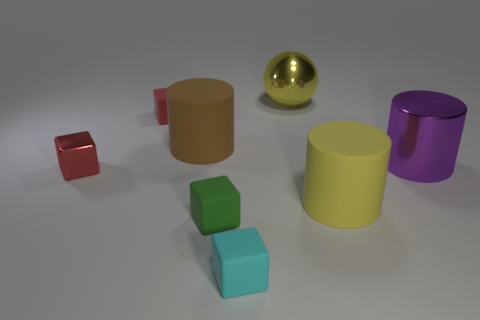The matte object that is the same color as the tiny metallic thing is what shape?
Your answer should be very brief. Cube. What is the size of the object that is the same color as the ball?
Offer a terse response. Large. Is there anything else that is the same material as the green thing?
Your answer should be compact. Yes. Are there more small rubber blocks that are in front of the small red rubber thing than purple cylinders?
Offer a terse response. Yes. Is there a green matte thing behind the big yellow thing to the right of the big ball on the left side of the purple cylinder?
Your answer should be compact. No. There is a big brown rubber thing; are there any big cylinders in front of it?
Give a very brief answer. Yes. How many other balls are the same color as the big sphere?
Offer a terse response. 0. There is another cylinder that is the same material as the brown cylinder; what is its size?
Offer a very short reply. Large. What is the size of the rubber cube that is behind the big yellow thing that is in front of the metallic object that is on the right side of the big sphere?
Keep it short and to the point. Small. What size is the matte thing right of the yellow metallic thing?
Provide a succinct answer. Large. 